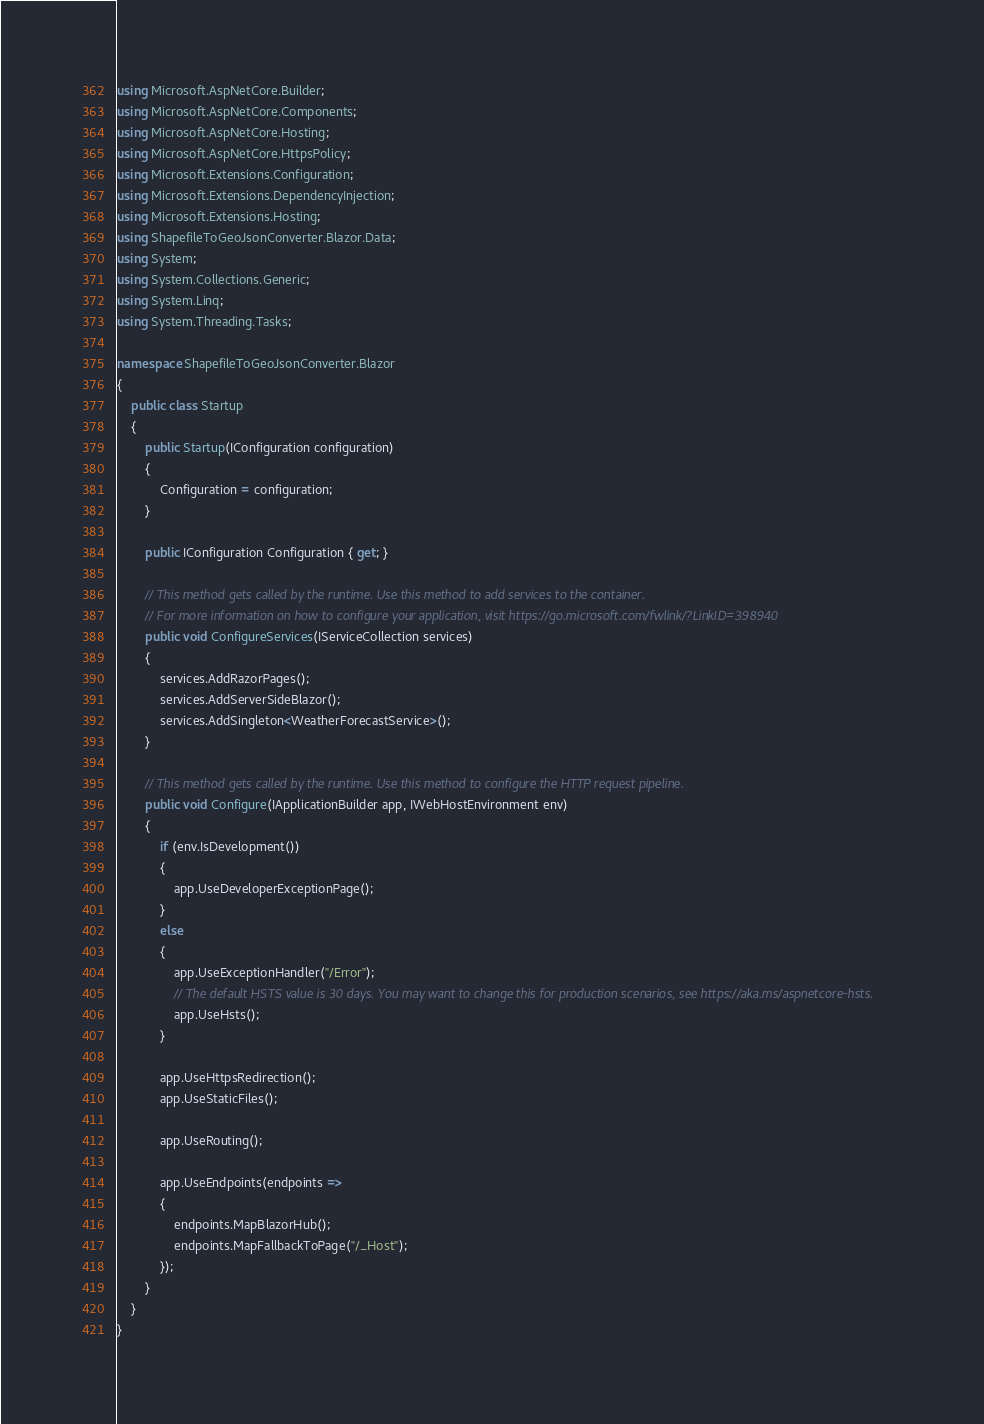<code> <loc_0><loc_0><loc_500><loc_500><_C#_>using Microsoft.AspNetCore.Builder;
using Microsoft.AspNetCore.Components;
using Microsoft.AspNetCore.Hosting;
using Microsoft.AspNetCore.HttpsPolicy;
using Microsoft.Extensions.Configuration;
using Microsoft.Extensions.DependencyInjection;
using Microsoft.Extensions.Hosting;
using ShapefileToGeoJsonConverter.Blazor.Data;
using System;
using System.Collections.Generic;
using System.Linq;
using System.Threading.Tasks;

namespace ShapefileToGeoJsonConverter.Blazor
{
    public class Startup
    {
        public Startup(IConfiguration configuration)
        {
            Configuration = configuration;
        }

        public IConfiguration Configuration { get; }

        // This method gets called by the runtime. Use this method to add services to the container.
        // For more information on how to configure your application, visit https://go.microsoft.com/fwlink/?LinkID=398940
        public void ConfigureServices(IServiceCollection services)
        {
            services.AddRazorPages();
            services.AddServerSideBlazor();
            services.AddSingleton<WeatherForecastService>();
        }

        // This method gets called by the runtime. Use this method to configure the HTTP request pipeline.
        public void Configure(IApplicationBuilder app, IWebHostEnvironment env)
        {
            if (env.IsDevelopment())
            {
                app.UseDeveloperExceptionPage();
            }
            else
            {
                app.UseExceptionHandler("/Error");
                // The default HSTS value is 30 days. You may want to change this for production scenarios, see https://aka.ms/aspnetcore-hsts.
                app.UseHsts();
            }

            app.UseHttpsRedirection();
            app.UseStaticFiles();

            app.UseRouting();

            app.UseEndpoints(endpoints =>
            {
                endpoints.MapBlazorHub();
                endpoints.MapFallbackToPage("/_Host");
            });
        }
    }
}
</code> 